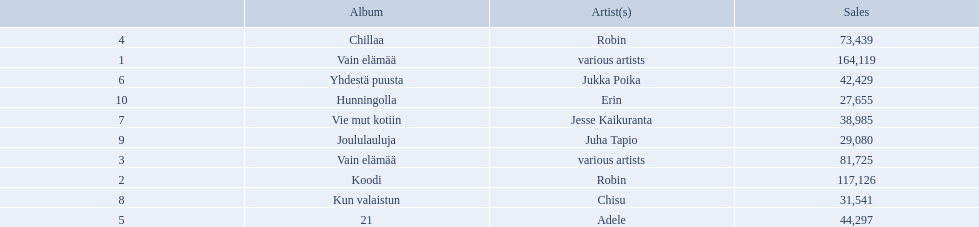Which albums had number-one albums in finland in 2012? 1, Vain elämää, Koodi, Vain elämää, Chillaa, 21, Yhdestä puusta, Vie mut kotiin, Kun valaistun, Joululauluja, Hunningolla. Of those albums, which were recorded by only one artist? Koodi, Chillaa, 21, Yhdestä puusta, Vie mut kotiin, Kun valaistun, Joululauluja, Hunningolla. Which albums made between 30,000 and 45,000 in sales? 21, Yhdestä puusta, Vie mut kotiin, Kun valaistun. Of those albums which had the highest sales? 21. Who was the artist for that album? Adele. 